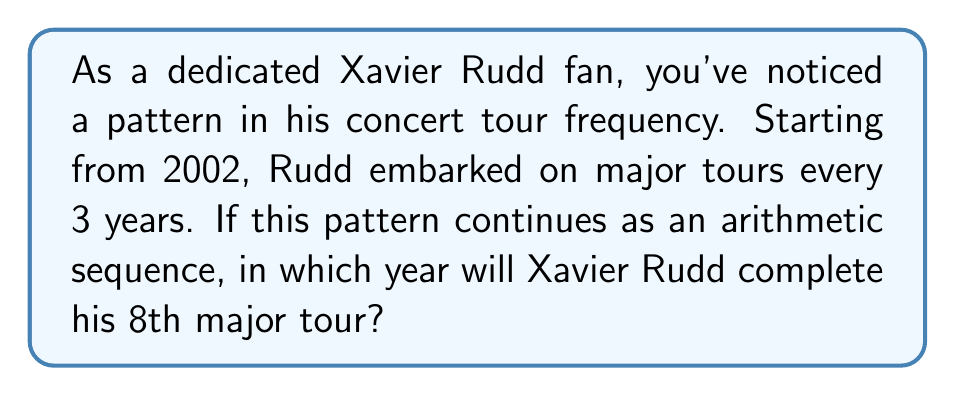Help me with this question. To solve this problem, we need to use the concept of arithmetic sequences. Let's break it down step-by-step:

1. Identify the sequence:
   - First term (a₁) = 2002 (year of the first tour)
   - Common difference (d) = 3 (years between tours)

2. We need to find the 8th term in this sequence. The formula for the nth term of an arithmetic sequence is:
   
   $a_n = a_1 + (n - 1)d$

   Where:
   $a_n$ is the nth term
   $a_1$ is the first term
   $n$ is the position of the term
   $d$ is the common difference

3. Plugging in our values:
   
   $a_8 = 2002 + (8 - 1)3$

4. Simplify:
   
   $a_8 = 2002 + (7)(3)$
   $a_8 = 2002 + 21$
   $a_8 = 2023$

Therefore, if Xavier Rudd continues this pattern, his 8th major tour will be completed in 2023.
Answer: 2023 